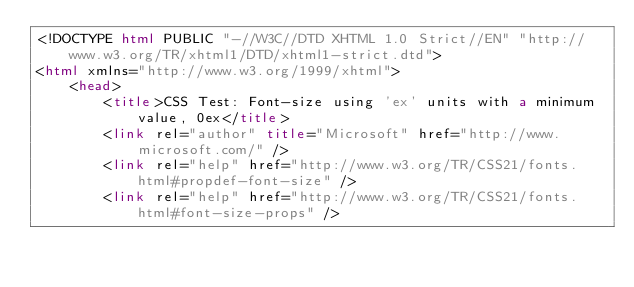<code> <loc_0><loc_0><loc_500><loc_500><_HTML_><!DOCTYPE html PUBLIC "-//W3C//DTD XHTML 1.0 Strict//EN" "http://www.w3.org/TR/xhtml1/DTD/xhtml1-strict.dtd">
<html xmlns="http://www.w3.org/1999/xhtml">
    <head>
        <title>CSS Test: Font-size using 'ex' units with a minimum value, 0ex</title>
        <link rel="author" title="Microsoft" href="http://www.microsoft.com/" />
        <link rel="help" href="http://www.w3.org/TR/CSS21/fonts.html#propdef-font-size" />
        <link rel="help" href="http://www.w3.org/TR/CSS21/fonts.html#font-size-props" /></code> 